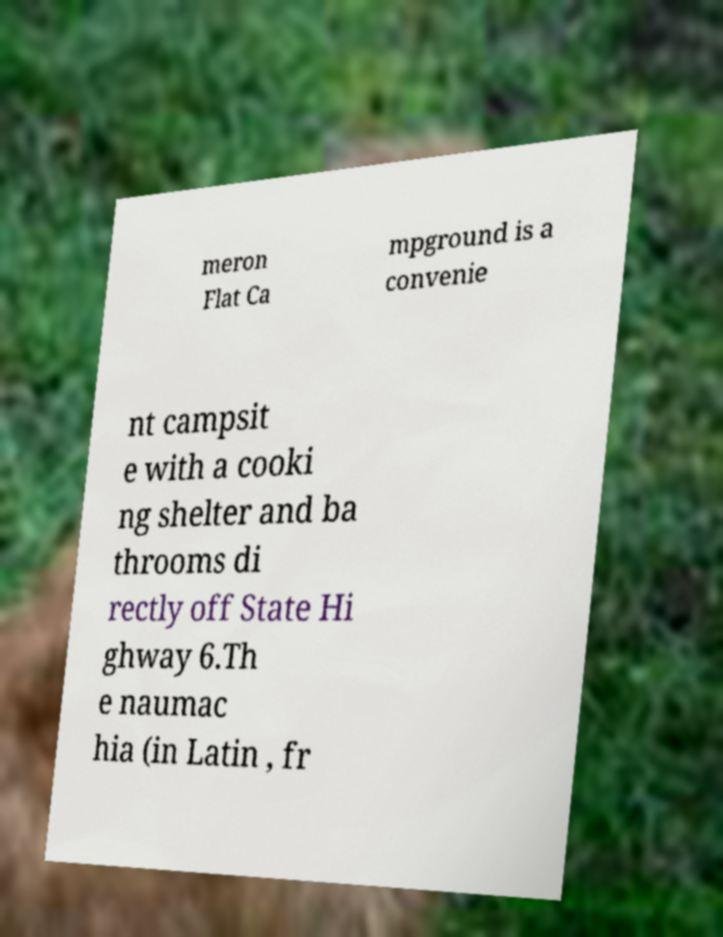What messages or text are displayed in this image? I need them in a readable, typed format. meron Flat Ca mpground is a convenie nt campsit e with a cooki ng shelter and ba throoms di rectly off State Hi ghway 6.Th e naumac hia (in Latin , fr 